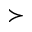<formula> <loc_0><loc_0><loc_500><loc_500>\succ</formula> 